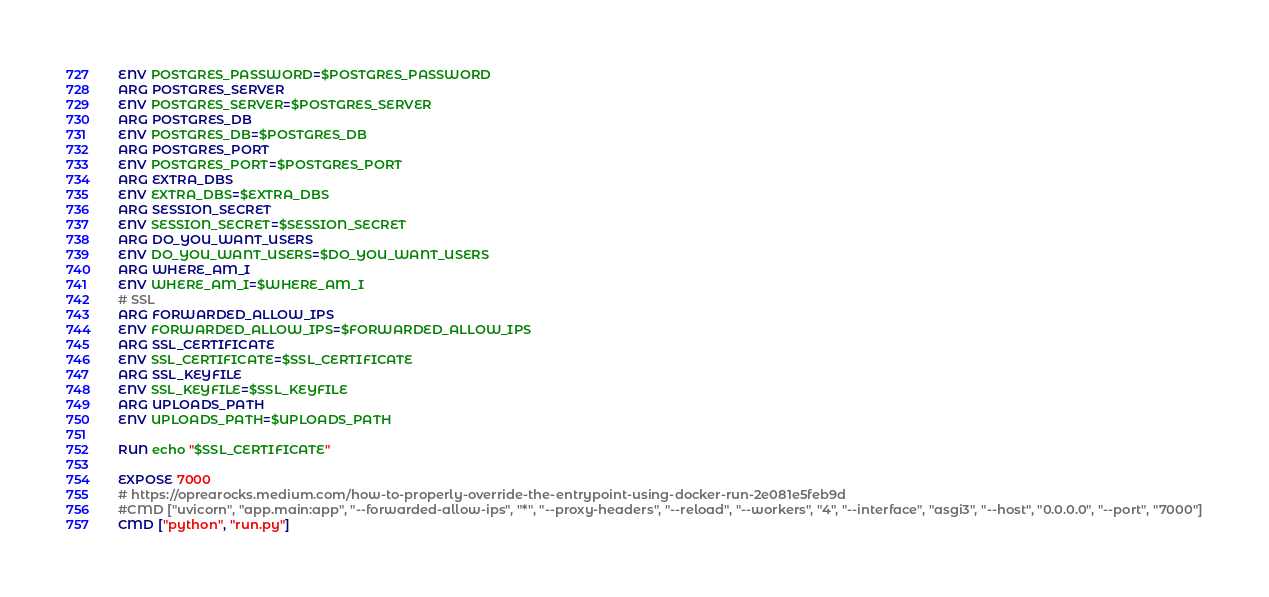<code> <loc_0><loc_0><loc_500><loc_500><_Dockerfile_>ENV POSTGRES_PASSWORD=$POSTGRES_PASSWORD
ARG POSTGRES_SERVER
ENV POSTGRES_SERVER=$POSTGRES_SERVER
ARG POSTGRES_DB
ENV POSTGRES_DB=$POSTGRES_DB
ARG POSTGRES_PORT
ENV POSTGRES_PORT=$POSTGRES_PORT
ARG EXTRA_DBS
ENV EXTRA_DBS=$EXTRA_DBS
ARG SESSION_SECRET
ENV SESSION_SECRET=$SESSION_SECRET
ARG DO_YOU_WANT_USERS
ENV DO_YOU_WANT_USERS=$DO_YOU_WANT_USERS
ARG WHERE_AM_I
ENV WHERE_AM_I=$WHERE_AM_I
# SSL
ARG FORWARDED_ALLOW_IPS
ENV FORWARDED_ALLOW_IPS=$FORWARDED_ALLOW_IPS
ARG SSL_CERTIFICATE
ENV SSL_CERTIFICATE=$SSL_CERTIFICATE
ARG SSL_KEYFILE
ENV SSL_KEYFILE=$SSL_KEYFILE
ARG UPLOADS_PATH
ENV UPLOADS_PATH=$UPLOADS_PATH

RUN echo "$SSL_CERTIFICATE"

EXPOSE 7000
# https://oprearocks.medium.com/how-to-properly-override-the-entrypoint-using-docker-run-2e081e5feb9d
#CMD ["uvicorn", "app.main:app", "--forwarded-allow-ips", "*", "--proxy-headers", "--reload", "--workers", "4", "--interface", "asgi3", "--host", "0.0.0.0", "--port", "7000"]
CMD ["python", "run.py"]</code> 